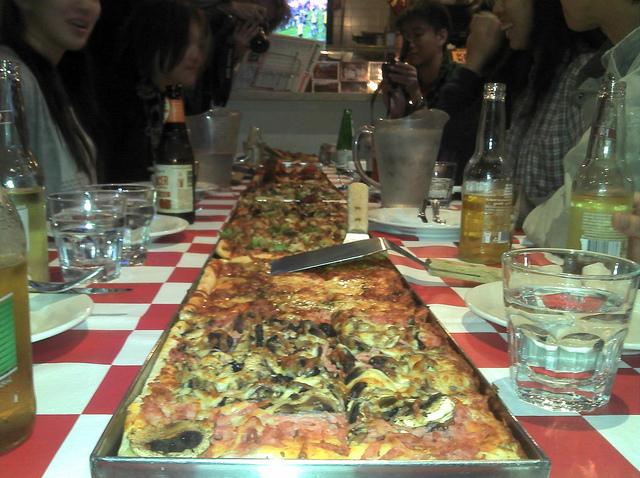What pattern is the tablecloth?
Quick response, please. Checkered. What is in the glasses?
Keep it brief. Water. How many pizzas are on the table?
Concise answer only. 4. 